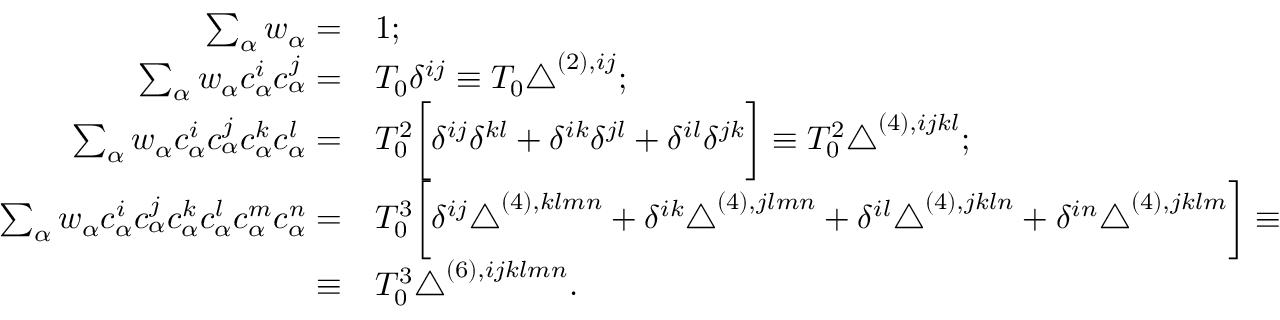Convert formula to latex. <formula><loc_0><loc_0><loc_500><loc_500>\begin{array} { r l } { \sum _ { \alpha } w _ { \alpha } = } & { 1 ; } \\ { \sum _ { \alpha } w _ { \alpha } c _ { \alpha } ^ { i } c _ { \alpha } ^ { j } = } & { T _ { 0 } \delta ^ { i j } \equiv T _ { 0 } \triangle ^ { ( 2 ) , i j } ; } \\ { \sum _ { \alpha } w _ { \alpha } c _ { \alpha } ^ { i } c _ { \alpha } ^ { j } c _ { \alpha } ^ { k } c _ { \alpha } ^ { l } = } & { T _ { 0 } ^ { 2 } \left [ \delta ^ { i j } \delta ^ { k l } + \delta ^ { i k } \delta ^ { j l } + \delta ^ { i l } \delta ^ { j k } \right ] \equiv T _ { 0 } ^ { 2 } \triangle ^ { ( 4 ) , i j k l } ; } \\ { \sum _ { \alpha } w _ { \alpha } c _ { \alpha } ^ { i } c _ { \alpha } ^ { j } c _ { \alpha } ^ { k } c _ { \alpha } ^ { l } c _ { \alpha } ^ { m } c _ { \alpha } ^ { n } = } & { T _ { 0 } ^ { 3 } \left [ \delta ^ { i j } \triangle ^ { ( 4 ) , k l m n } + \delta ^ { i k } \triangle ^ { ( 4 ) , j l m n } + \delta ^ { i l } \triangle ^ { ( 4 ) , j k \ln } + \delta ^ { i n } \triangle ^ { ( 4 ) , j k l m } \right ] \equiv } \\ { \equiv } & { T _ { 0 } ^ { 3 } \triangle ^ { ( 6 ) , i j k l m n } . } \end{array}</formula> 